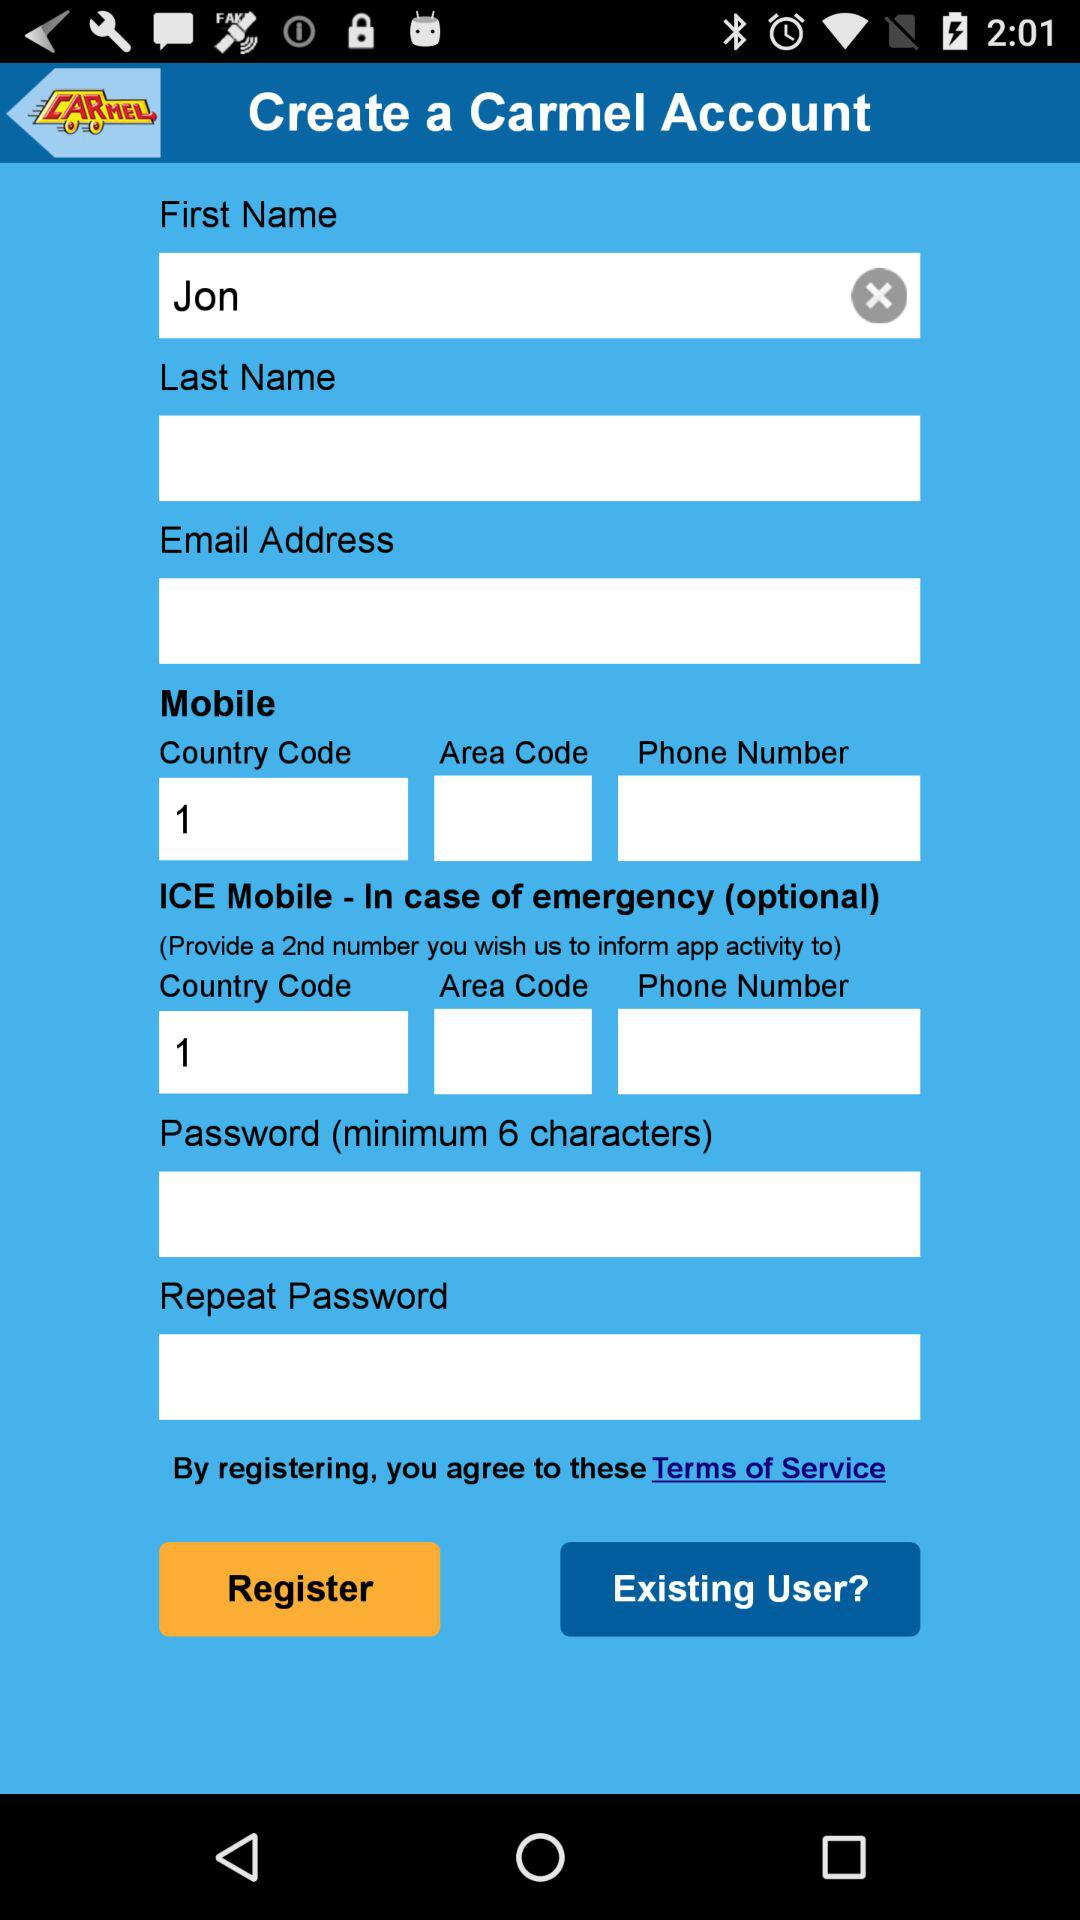What is the minimum length of characters for the password? The minimum length of characters for the password is 6. 